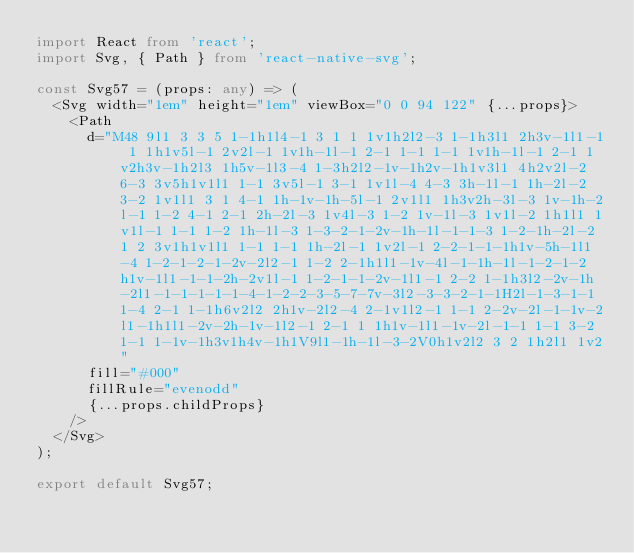Convert code to text. <code><loc_0><loc_0><loc_500><loc_500><_TypeScript_>import React from 'react';
import Svg, { Path } from 'react-native-svg';

const Svg57 = (props: any) => (
  <Svg width="1em" height="1em" viewBox="0 0 94 122" {...props}>
    <Path
      d="M48 9l1 3 3 5 1-1h1l4-1 3 1 1 1v1h2l2-3 1-1h3l1 2h3v-1l1-1 1 1h1v5l-1 2v2l-1 1v1h-1l-1 2-1 1-1 1-1 1v1h-1l-1 2-1 1v2h3v-1h2l3 1h5v-1l3-4 1-3h2l2-1v-1h2v-1h1v3l1 4h2v2l-2 6-3 3v5h1v1l1 1-1 3v5l-1 3-1 1v1l-4 4-3 3h-1l-1 1h-2l-2 3-2 1v1l1 3 1 4-1 1h-1v-1h-5l-1 2v1l1 1h3v2h-3l-3 1v-1h-2l-1 1-2 4-1 2-1 2h-2l-3 1v4l-3 1-2 1v-1l-3 1v1l-2 1h1l1 1v1l-1 1-1 1-2 1h-1l-3 1-3-2-1-2v-1h-1l-1-1-3 1-2-1h-2l-2 1 2 3v1h1v1l1 1-1 1-1 1h-2l-1 1v2l-1 2-2-1-1-1h1v-5h-1l1-4 1-2-1-2-1-2v-2l2-1 1-2 2-1h1l1-1v-4l-1-1h-1l-1-2-1-2h1v-1l1-1-1-2h-2v1l-1 1-2-1-1-2v-1l1-1 2-2 1-1h3l2-2v-1h-2l1-1-1-1-1-1-4-1-2-2-3-5-7-7v-3l2-3-3-2-1-1H2l-1-3-1-1 1-4 2-1 1-1h6v2l2 2h1v-2l2-4 2-1v1l2-1 1-1 2-2v-2l-1-1v-2l1-1h1l1-2v-2h-1v-1l2-1 2-1 1 1h1v-1l1-1v-2l-1-1 1-1 3-2 1-1 1-1v-1h3v1h4v-1h1V9l1-1h-1l-3-2V0h1v2l2 3 2 1h2l1 1v2"
      fill="#000"
      fillRule="evenodd"
      {...props.childProps}
    />
  </Svg>
);

export default Svg57;
</code> 